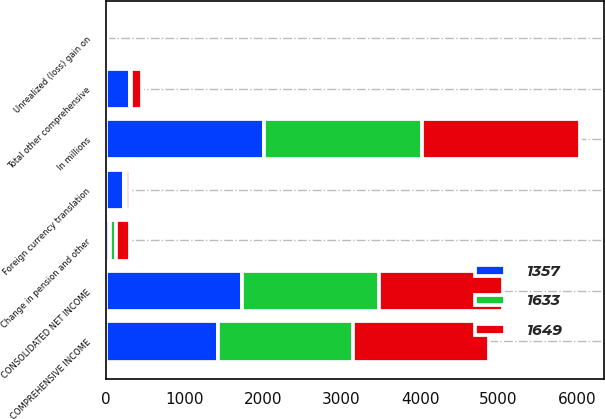<chart> <loc_0><loc_0><loc_500><loc_500><stacked_bar_chart><ecel><fcel>In millions<fcel>CONSOLIDATED NET INCOME<fcel>Foreign currency translation<fcel>Unrealized (loss) gain on<fcel>Change in pension and other<fcel>Total other comprehensive<fcel>COMPREHENSIVE INCOME<nl><fcel>1357<fcel>2014<fcel>1736<fcel>234<fcel>12<fcel>58<fcel>305<fcel>1431<nl><fcel>1649<fcel>2013<fcel>1588<fcel>46<fcel>1<fcel>183<fcel>137<fcel>1725<nl><fcel>1633<fcel>2012<fcel>1738<fcel>29<fcel>2<fcel>70<fcel>19<fcel>1719<nl></chart> 